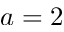<formula> <loc_0><loc_0><loc_500><loc_500>a = 2</formula> 